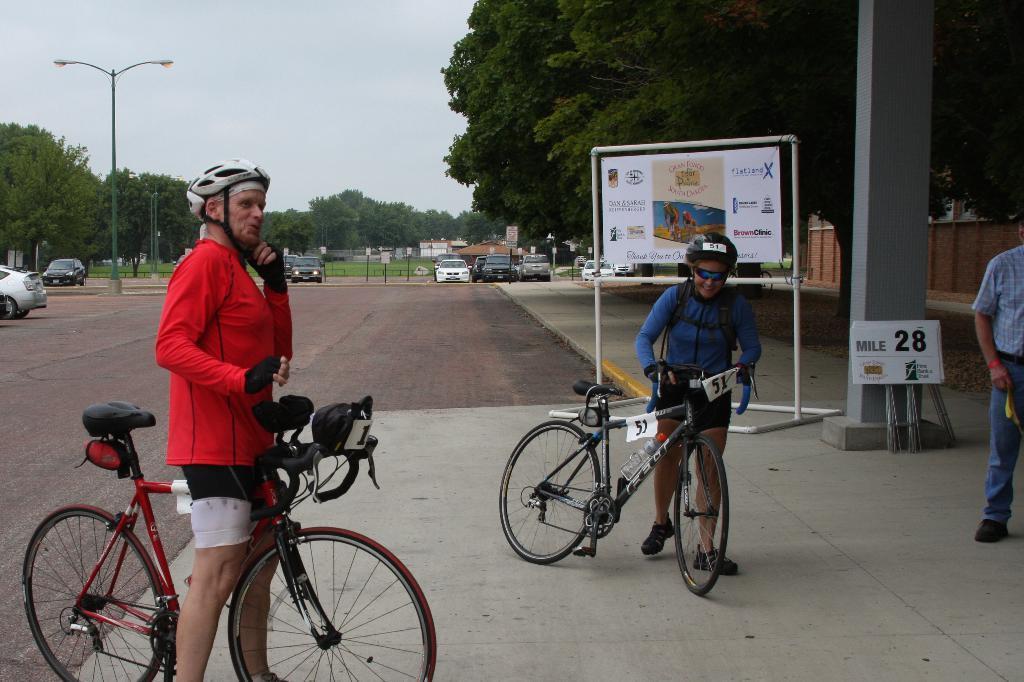How would you summarize this image in a sentence or two? In this image, I can see two persons standing on the pathway and holding the bicycles. Behind a person, I can see a board with the poles. On the right side of the image, I can see another person standing, a pillar, boards and a wall. In the background, there are vehicles, trees, a street light and the sky. 